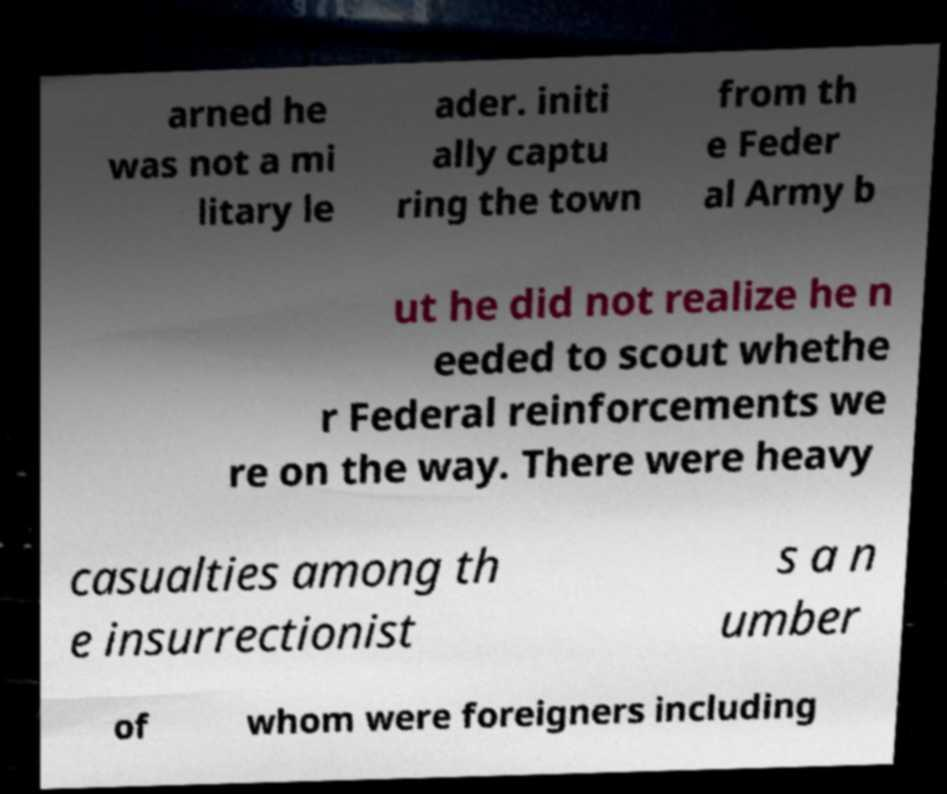Can you accurately transcribe the text from the provided image for me? arned he was not a mi litary le ader. initi ally captu ring the town from th e Feder al Army b ut he did not realize he n eeded to scout whethe r Federal reinforcements we re on the way. There were heavy casualties among th e insurrectionist s a n umber of whom were foreigners including 